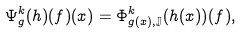<formula> <loc_0><loc_0><loc_500><loc_500>\Psi _ { g } ^ { k } ( h ) ( f ) ( x ) = \Phi _ { g ( x ) , \mathbb { J } } ^ { k } ( h ( x ) ) ( f ) ,</formula> 